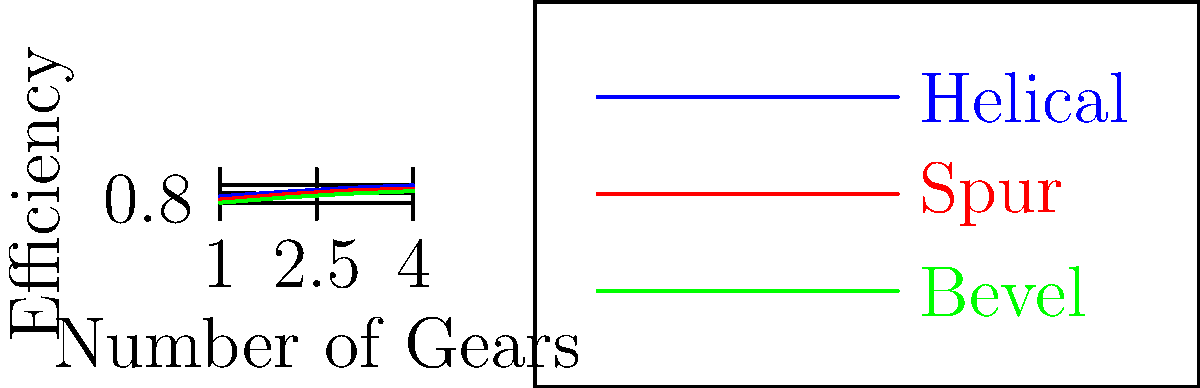As an investment analyst evaluating a new automotive startup in New York City, you're analyzing their innovative transmission system. The graph shows the efficiency of three different gear configurations (Helical, Spur, and Bevel) as the number of gears increases. If the startup claims their 4-gear transmission system achieves 90% efficiency, which gear configuration are they most likely using, and how might this impact their market position? To answer this question, we need to analyze the graph and understand its implications:

1. Observe the efficiency trends:
   - Helical gears (blue line) show the highest efficiency across all gear numbers.
   - Spur gears (red line) have medium efficiency.
   - Bevel gears (green line) have the lowest efficiency.

2. Focus on the 4-gear system (x-axis = 4):
   - Helical gears: approximately 92% efficient
   - Spur gears: approximately 87% efficient
   - Bevel gears: approximately 83% efficient

3. Compare with the claimed 90% efficiency:
   - Only the helical gear configuration exceeds 90% efficiency at 4 gears.

4. Market position impact:
   - Higher efficiency translates to better fuel economy and performance.
   - Helical gears, while more efficient, are typically more expensive to manufacture.
   - The startup's use of high-efficiency gears suggests a focus on premium performance, which could position them well in the high-end market.

5. Investment perspective:
   - The startup's choice of high-efficiency gears indicates a commitment to quality and performance.
   - This could justify a higher price point and potentially higher profit margins.
   - However, higher production costs might impact initial profitability or require more capital investment.
Answer: Helical gears; positions startup in premium market segment with performance advantage but potentially higher costs. 